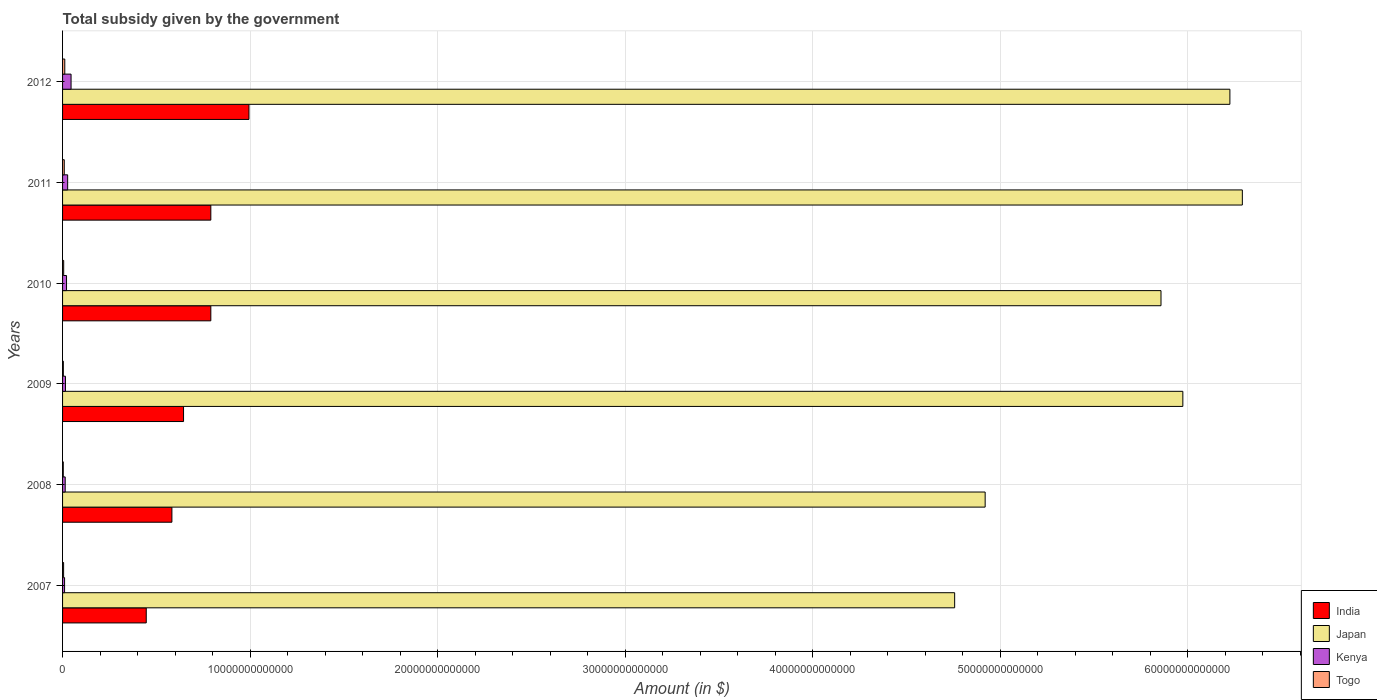How many different coloured bars are there?
Make the answer very short. 4. How many bars are there on the 2nd tick from the top?
Your answer should be very brief. 4. What is the label of the 3rd group of bars from the top?
Your answer should be very brief. 2010. What is the total revenue collected by the government in Togo in 2012?
Provide a succinct answer. 1.18e+11. Across all years, what is the maximum total revenue collected by the government in Kenya?
Provide a succinct answer. 4.53e+11. Across all years, what is the minimum total revenue collected by the government in India?
Offer a terse response. 4.46e+12. What is the total total revenue collected by the government in India in the graph?
Give a very brief answer. 4.25e+13. What is the difference between the total revenue collected by the government in India in 2009 and that in 2011?
Provide a succinct answer. -1.45e+12. What is the difference between the total revenue collected by the government in Togo in 2009 and the total revenue collected by the government in Japan in 2008?
Give a very brief answer. -4.92e+13. What is the average total revenue collected by the government in Kenya per year?
Your answer should be very brief. 2.23e+11. In the year 2009, what is the difference between the total revenue collected by the government in Japan and total revenue collected by the government in India?
Your response must be concise. 5.33e+13. What is the ratio of the total revenue collected by the government in Kenya in 2010 to that in 2012?
Your answer should be compact. 0.47. Is the total revenue collected by the government in Togo in 2010 less than that in 2012?
Provide a short and direct response. Yes. Is the difference between the total revenue collected by the government in Japan in 2008 and 2010 greater than the difference between the total revenue collected by the government in India in 2008 and 2010?
Ensure brevity in your answer.  No. What is the difference between the highest and the second highest total revenue collected by the government in Japan?
Your response must be concise. 6.64e+11. What is the difference between the highest and the lowest total revenue collected by the government in Kenya?
Ensure brevity in your answer.  3.46e+11. Is it the case that in every year, the sum of the total revenue collected by the government in Togo and total revenue collected by the government in Japan is greater than the sum of total revenue collected by the government in India and total revenue collected by the government in Kenya?
Make the answer very short. Yes. What does the 2nd bar from the top in 2012 represents?
Keep it short and to the point. Kenya. How many years are there in the graph?
Make the answer very short. 6. What is the difference between two consecutive major ticks on the X-axis?
Make the answer very short. 1.00e+13. Does the graph contain any zero values?
Your answer should be very brief. No. Does the graph contain grids?
Offer a terse response. Yes. What is the title of the graph?
Provide a short and direct response. Total subsidy given by the government. Does "Uzbekistan" appear as one of the legend labels in the graph?
Offer a very short reply. No. What is the label or title of the X-axis?
Make the answer very short. Amount (in $). What is the label or title of the Y-axis?
Provide a succinct answer. Years. What is the Amount (in $) of India in 2007?
Provide a short and direct response. 4.46e+12. What is the Amount (in $) of Japan in 2007?
Your answer should be compact. 4.76e+13. What is the Amount (in $) of Kenya in 2007?
Offer a terse response. 1.08e+11. What is the Amount (in $) of Togo in 2007?
Keep it short and to the point. 5.57e+1. What is the Amount (in $) in India in 2008?
Give a very brief answer. 5.83e+12. What is the Amount (in $) of Japan in 2008?
Give a very brief answer. 4.92e+13. What is the Amount (in $) in Kenya in 2008?
Provide a short and direct response. 1.41e+11. What is the Amount (in $) in Togo in 2008?
Your answer should be compact. 3.81e+1. What is the Amount (in $) in India in 2009?
Your answer should be compact. 6.45e+12. What is the Amount (in $) of Japan in 2009?
Offer a terse response. 5.97e+13. What is the Amount (in $) of Kenya in 2009?
Provide a succinct answer. 1.55e+11. What is the Amount (in $) in Togo in 2009?
Give a very brief answer. 4.11e+1. What is the Amount (in $) of India in 2010?
Your answer should be very brief. 7.90e+12. What is the Amount (in $) in Japan in 2010?
Your answer should be very brief. 5.86e+13. What is the Amount (in $) of Kenya in 2010?
Provide a succinct answer. 2.12e+11. What is the Amount (in $) in Togo in 2010?
Offer a terse response. 5.96e+1. What is the Amount (in $) in India in 2011?
Ensure brevity in your answer.  7.90e+12. What is the Amount (in $) in Japan in 2011?
Offer a very short reply. 6.29e+13. What is the Amount (in $) in Kenya in 2011?
Keep it short and to the point. 2.72e+11. What is the Amount (in $) of Togo in 2011?
Your response must be concise. 9.10e+1. What is the Amount (in $) in India in 2012?
Ensure brevity in your answer.  9.94e+12. What is the Amount (in $) of Japan in 2012?
Provide a succinct answer. 6.22e+13. What is the Amount (in $) in Kenya in 2012?
Keep it short and to the point. 4.53e+11. What is the Amount (in $) of Togo in 2012?
Provide a short and direct response. 1.18e+11. Across all years, what is the maximum Amount (in $) in India?
Ensure brevity in your answer.  9.94e+12. Across all years, what is the maximum Amount (in $) of Japan?
Make the answer very short. 6.29e+13. Across all years, what is the maximum Amount (in $) in Kenya?
Keep it short and to the point. 4.53e+11. Across all years, what is the maximum Amount (in $) in Togo?
Provide a succinct answer. 1.18e+11. Across all years, what is the minimum Amount (in $) of India?
Provide a succinct answer. 4.46e+12. Across all years, what is the minimum Amount (in $) in Japan?
Give a very brief answer. 4.76e+13. Across all years, what is the minimum Amount (in $) of Kenya?
Your response must be concise. 1.08e+11. Across all years, what is the minimum Amount (in $) in Togo?
Offer a very short reply. 3.81e+1. What is the total Amount (in $) in India in the graph?
Offer a terse response. 4.25e+13. What is the total Amount (in $) in Japan in the graph?
Your answer should be compact. 3.40e+14. What is the total Amount (in $) of Kenya in the graph?
Your response must be concise. 1.34e+12. What is the total Amount (in $) of Togo in the graph?
Your response must be concise. 4.03e+11. What is the difference between the Amount (in $) in India in 2007 and that in 2008?
Make the answer very short. -1.37e+12. What is the difference between the Amount (in $) of Japan in 2007 and that in 2008?
Your response must be concise. -1.63e+12. What is the difference between the Amount (in $) in Kenya in 2007 and that in 2008?
Your response must be concise. -3.34e+1. What is the difference between the Amount (in $) of Togo in 2007 and that in 2008?
Your response must be concise. 1.75e+1. What is the difference between the Amount (in $) in India in 2007 and that in 2009?
Ensure brevity in your answer.  -1.99e+12. What is the difference between the Amount (in $) in Japan in 2007 and that in 2009?
Ensure brevity in your answer.  -1.22e+13. What is the difference between the Amount (in $) in Kenya in 2007 and that in 2009?
Offer a terse response. -4.70e+1. What is the difference between the Amount (in $) of Togo in 2007 and that in 2009?
Your answer should be compact. 1.46e+1. What is the difference between the Amount (in $) in India in 2007 and that in 2010?
Provide a succinct answer. -3.44e+12. What is the difference between the Amount (in $) of Japan in 2007 and that in 2010?
Provide a short and direct response. -1.10e+13. What is the difference between the Amount (in $) in Kenya in 2007 and that in 2010?
Your answer should be compact. -1.04e+11. What is the difference between the Amount (in $) in Togo in 2007 and that in 2010?
Your answer should be compact. -3.97e+09. What is the difference between the Amount (in $) in India in 2007 and that in 2011?
Give a very brief answer. -3.44e+12. What is the difference between the Amount (in $) in Japan in 2007 and that in 2011?
Keep it short and to the point. -1.53e+13. What is the difference between the Amount (in $) in Kenya in 2007 and that in 2011?
Keep it short and to the point. -1.64e+11. What is the difference between the Amount (in $) of Togo in 2007 and that in 2011?
Ensure brevity in your answer.  -3.53e+1. What is the difference between the Amount (in $) in India in 2007 and that in 2012?
Provide a short and direct response. -5.48e+12. What is the difference between the Amount (in $) of Japan in 2007 and that in 2012?
Your response must be concise. -1.47e+13. What is the difference between the Amount (in $) of Kenya in 2007 and that in 2012?
Your answer should be very brief. -3.46e+11. What is the difference between the Amount (in $) in Togo in 2007 and that in 2012?
Give a very brief answer. -6.22e+1. What is the difference between the Amount (in $) in India in 2008 and that in 2009?
Give a very brief answer. -6.20e+11. What is the difference between the Amount (in $) in Japan in 2008 and that in 2009?
Your answer should be very brief. -1.05e+13. What is the difference between the Amount (in $) of Kenya in 2008 and that in 2009?
Provide a short and direct response. -1.37e+1. What is the difference between the Amount (in $) in Togo in 2008 and that in 2009?
Offer a terse response. -2.97e+09. What is the difference between the Amount (in $) of India in 2008 and that in 2010?
Your answer should be very brief. -2.07e+12. What is the difference between the Amount (in $) in Japan in 2008 and that in 2010?
Give a very brief answer. -9.38e+12. What is the difference between the Amount (in $) in Kenya in 2008 and that in 2010?
Offer a very short reply. -7.07e+1. What is the difference between the Amount (in $) in Togo in 2008 and that in 2010?
Ensure brevity in your answer.  -2.15e+1. What is the difference between the Amount (in $) in India in 2008 and that in 2011?
Offer a terse response. -2.07e+12. What is the difference between the Amount (in $) in Japan in 2008 and that in 2011?
Your answer should be very brief. -1.37e+13. What is the difference between the Amount (in $) in Kenya in 2008 and that in 2011?
Offer a terse response. -1.31e+11. What is the difference between the Amount (in $) of Togo in 2008 and that in 2011?
Your answer should be very brief. -5.28e+1. What is the difference between the Amount (in $) in India in 2008 and that in 2012?
Keep it short and to the point. -4.11e+12. What is the difference between the Amount (in $) in Japan in 2008 and that in 2012?
Ensure brevity in your answer.  -1.30e+13. What is the difference between the Amount (in $) in Kenya in 2008 and that in 2012?
Offer a very short reply. -3.12e+11. What is the difference between the Amount (in $) of Togo in 2008 and that in 2012?
Keep it short and to the point. -7.97e+1. What is the difference between the Amount (in $) in India in 2009 and that in 2010?
Your answer should be very brief. -1.45e+12. What is the difference between the Amount (in $) of Japan in 2009 and that in 2010?
Keep it short and to the point. 1.16e+12. What is the difference between the Amount (in $) of Kenya in 2009 and that in 2010?
Make the answer very short. -5.71e+1. What is the difference between the Amount (in $) of Togo in 2009 and that in 2010?
Offer a terse response. -1.85e+1. What is the difference between the Amount (in $) in India in 2009 and that in 2011?
Make the answer very short. -1.45e+12. What is the difference between the Amount (in $) in Japan in 2009 and that in 2011?
Make the answer very short. -3.17e+12. What is the difference between the Amount (in $) in Kenya in 2009 and that in 2011?
Provide a short and direct response. -1.17e+11. What is the difference between the Amount (in $) of Togo in 2009 and that in 2011?
Provide a short and direct response. -4.99e+1. What is the difference between the Amount (in $) in India in 2009 and that in 2012?
Your answer should be compact. -3.49e+12. What is the difference between the Amount (in $) in Japan in 2009 and that in 2012?
Ensure brevity in your answer.  -2.51e+12. What is the difference between the Amount (in $) of Kenya in 2009 and that in 2012?
Provide a short and direct response. -2.99e+11. What is the difference between the Amount (in $) in Togo in 2009 and that in 2012?
Offer a very short reply. -7.67e+1. What is the difference between the Amount (in $) of India in 2010 and that in 2011?
Your response must be concise. 0. What is the difference between the Amount (in $) in Japan in 2010 and that in 2011?
Offer a terse response. -4.34e+12. What is the difference between the Amount (in $) of Kenya in 2010 and that in 2011?
Provide a succinct answer. -6.00e+1. What is the difference between the Amount (in $) in Togo in 2010 and that in 2011?
Ensure brevity in your answer.  -3.13e+1. What is the difference between the Amount (in $) in India in 2010 and that in 2012?
Your answer should be very brief. -2.03e+12. What is the difference between the Amount (in $) in Japan in 2010 and that in 2012?
Provide a short and direct response. -3.67e+12. What is the difference between the Amount (in $) in Kenya in 2010 and that in 2012?
Ensure brevity in your answer.  -2.42e+11. What is the difference between the Amount (in $) in Togo in 2010 and that in 2012?
Offer a terse response. -5.82e+1. What is the difference between the Amount (in $) in India in 2011 and that in 2012?
Your answer should be compact. -2.03e+12. What is the difference between the Amount (in $) of Japan in 2011 and that in 2012?
Your answer should be very brief. 6.64e+11. What is the difference between the Amount (in $) of Kenya in 2011 and that in 2012?
Offer a terse response. -1.82e+11. What is the difference between the Amount (in $) in Togo in 2011 and that in 2012?
Ensure brevity in your answer.  -2.69e+1. What is the difference between the Amount (in $) in India in 2007 and the Amount (in $) in Japan in 2008?
Provide a short and direct response. -4.47e+13. What is the difference between the Amount (in $) of India in 2007 and the Amount (in $) of Kenya in 2008?
Keep it short and to the point. 4.32e+12. What is the difference between the Amount (in $) of India in 2007 and the Amount (in $) of Togo in 2008?
Provide a short and direct response. 4.42e+12. What is the difference between the Amount (in $) of Japan in 2007 and the Amount (in $) of Kenya in 2008?
Make the answer very short. 4.74e+13. What is the difference between the Amount (in $) in Japan in 2007 and the Amount (in $) in Togo in 2008?
Keep it short and to the point. 4.75e+13. What is the difference between the Amount (in $) in Kenya in 2007 and the Amount (in $) in Togo in 2008?
Give a very brief answer. 6.94e+1. What is the difference between the Amount (in $) in India in 2007 and the Amount (in $) in Japan in 2009?
Offer a very short reply. -5.53e+13. What is the difference between the Amount (in $) of India in 2007 and the Amount (in $) of Kenya in 2009?
Provide a succinct answer. 4.31e+12. What is the difference between the Amount (in $) in India in 2007 and the Amount (in $) in Togo in 2009?
Offer a terse response. 4.42e+12. What is the difference between the Amount (in $) in Japan in 2007 and the Amount (in $) in Kenya in 2009?
Your response must be concise. 4.74e+13. What is the difference between the Amount (in $) of Japan in 2007 and the Amount (in $) of Togo in 2009?
Your answer should be compact. 4.75e+13. What is the difference between the Amount (in $) in Kenya in 2007 and the Amount (in $) in Togo in 2009?
Your response must be concise. 6.65e+1. What is the difference between the Amount (in $) of India in 2007 and the Amount (in $) of Japan in 2010?
Your answer should be compact. -5.41e+13. What is the difference between the Amount (in $) of India in 2007 and the Amount (in $) of Kenya in 2010?
Your answer should be very brief. 4.25e+12. What is the difference between the Amount (in $) in India in 2007 and the Amount (in $) in Togo in 2010?
Your response must be concise. 4.40e+12. What is the difference between the Amount (in $) of Japan in 2007 and the Amount (in $) of Kenya in 2010?
Your answer should be compact. 4.74e+13. What is the difference between the Amount (in $) of Japan in 2007 and the Amount (in $) of Togo in 2010?
Offer a very short reply. 4.75e+13. What is the difference between the Amount (in $) in Kenya in 2007 and the Amount (in $) in Togo in 2010?
Your answer should be very brief. 4.79e+1. What is the difference between the Amount (in $) of India in 2007 and the Amount (in $) of Japan in 2011?
Provide a short and direct response. -5.84e+13. What is the difference between the Amount (in $) of India in 2007 and the Amount (in $) of Kenya in 2011?
Keep it short and to the point. 4.19e+12. What is the difference between the Amount (in $) of India in 2007 and the Amount (in $) of Togo in 2011?
Your answer should be compact. 4.37e+12. What is the difference between the Amount (in $) in Japan in 2007 and the Amount (in $) in Kenya in 2011?
Give a very brief answer. 4.73e+13. What is the difference between the Amount (in $) of Japan in 2007 and the Amount (in $) of Togo in 2011?
Ensure brevity in your answer.  4.75e+13. What is the difference between the Amount (in $) in Kenya in 2007 and the Amount (in $) in Togo in 2011?
Make the answer very short. 1.66e+1. What is the difference between the Amount (in $) in India in 2007 and the Amount (in $) in Japan in 2012?
Your answer should be very brief. -5.78e+13. What is the difference between the Amount (in $) in India in 2007 and the Amount (in $) in Kenya in 2012?
Your response must be concise. 4.01e+12. What is the difference between the Amount (in $) in India in 2007 and the Amount (in $) in Togo in 2012?
Keep it short and to the point. 4.34e+12. What is the difference between the Amount (in $) of Japan in 2007 and the Amount (in $) of Kenya in 2012?
Make the answer very short. 4.71e+13. What is the difference between the Amount (in $) of Japan in 2007 and the Amount (in $) of Togo in 2012?
Give a very brief answer. 4.74e+13. What is the difference between the Amount (in $) of Kenya in 2007 and the Amount (in $) of Togo in 2012?
Offer a very short reply. -1.03e+1. What is the difference between the Amount (in $) of India in 2008 and the Amount (in $) of Japan in 2009?
Keep it short and to the point. -5.39e+13. What is the difference between the Amount (in $) of India in 2008 and the Amount (in $) of Kenya in 2009?
Your answer should be compact. 5.68e+12. What is the difference between the Amount (in $) of India in 2008 and the Amount (in $) of Togo in 2009?
Your response must be concise. 5.79e+12. What is the difference between the Amount (in $) of Japan in 2008 and the Amount (in $) of Kenya in 2009?
Keep it short and to the point. 4.90e+13. What is the difference between the Amount (in $) of Japan in 2008 and the Amount (in $) of Togo in 2009?
Provide a short and direct response. 4.92e+13. What is the difference between the Amount (in $) in Kenya in 2008 and the Amount (in $) in Togo in 2009?
Ensure brevity in your answer.  9.98e+1. What is the difference between the Amount (in $) of India in 2008 and the Amount (in $) of Japan in 2010?
Give a very brief answer. -5.27e+13. What is the difference between the Amount (in $) in India in 2008 and the Amount (in $) in Kenya in 2010?
Provide a succinct answer. 5.62e+12. What is the difference between the Amount (in $) in India in 2008 and the Amount (in $) in Togo in 2010?
Your answer should be compact. 5.77e+12. What is the difference between the Amount (in $) of Japan in 2008 and the Amount (in $) of Kenya in 2010?
Provide a short and direct response. 4.90e+13. What is the difference between the Amount (in $) of Japan in 2008 and the Amount (in $) of Togo in 2010?
Offer a very short reply. 4.91e+13. What is the difference between the Amount (in $) of Kenya in 2008 and the Amount (in $) of Togo in 2010?
Offer a very short reply. 8.13e+1. What is the difference between the Amount (in $) of India in 2008 and the Amount (in $) of Japan in 2011?
Your answer should be very brief. -5.71e+13. What is the difference between the Amount (in $) of India in 2008 and the Amount (in $) of Kenya in 2011?
Provide a succinct answer. 5.56e+12. What is the difference between the Amount (in $) in India in 2008 and the Amount (in $) in Togo in 2011?
Your answer should be compact. 5.74e+12. What is the difference between the Amount (in $) in Japan in 2008 and the Amount (in $) in Kenya in 2011?
Offer a very short reply. 4.89e+13. What is the difference between the Amount (in $) in Japan in 2008 and the Amount (in $) in Togo in 2011?
Offer a terse response. 4.91e+13. What is the difference between the Amount (in $) of Kenya in 2008 and the Amount (in $) of Togo in 2011?
Provide a succinct answer. 5.00e+1. What is the difference between the Amount (in $) in India in 2008 and the Amount (in $) in Japan in 2012?
Your answer should be very brief. -5.64e+13. What is the difference between the Amount (in $) in India in 2008 and the Amount (in $) in Kenya in 2012?
Offer a very short reply. 5.38e+12. What is the difference between the Amount (in $) in India in 2008 and the Amount (in $) in Togo in 2012?
Make the answer very short. 5.71e+12. What is the difference between the Amount (in $) in Japan in 2008 and the Amount (in $) in Kenya in 2012?
Provide a short and direct response. 4.87e+13. What is the difference between the Amount (in $) of Japan in 2008 and the Amount (in $) of Togo in 2012?
Make the answer very short. 4.91e+13. What is the difference between the Amount (in $) of Kenya in 2008 and the Amount (in $) of Togo in 2012?
Ensure brevity in your answer.  2.31e+1. What is the difference between the Amount (in $) in India in 2009 and the Amount (in $) in Japan in 2010?
Provide a short and direct response. -5.21e+13. What is the difference between the Amount (in $) in India in 2009 and the Amount (in $) in Kenya in 2010?
Offer a very short reply. 6.24e+12. What is the difference between the Amount (in $) of India in 2009 and the Amount (in $) of Togo in 2010?
Offer a terse response. 6.39e+12. What is the difference between the Amount (in $) of Japan in 2009 and the Amount (in $) of Kenya in 2010?
Provide a short and direct response. 5.95e+13. What is the difference between the Amount (in $) in Japan in 2009 and the Amount (in $) in Togo in 2010?
Your answer should be compact. 5.97e+13. What is the difference between the Amount (in $) of Kenya in 2009 and the Amount (in $) of Togo in 2010?
Offer a very short reply. 9.50e+1. What is the difference between the Amount (in $) of India in 2009 and the Amount (in $) of Japan in 2011?
Ensure brevity in your answer.  -5.65e+13. What is the difference between the Amount (in $) in India in 2009 and the Amount (in $) in Kenya in 2011?
Offer a very short reply. 6.18e+12. What is the difference between the Amount (in $) of India in 2009 and the Amount (in $) of Togo in 2011?
Ensure brevity in your answer.  6.36e+12. What is the difference between the Amount (in $) of Japan in 2009 and the Amount (in $) of Kenya in 2011?
Offer a terse response. 5.95e+13. What is the difference between the Amount (in $) of Japan in 2009 and the Amount (in $) of Togo in 2011?
Your response must be concise. 5.96e+13. What is the difference between the Amount (in $) in Kenya in 2009 and the Amount (in $) in Togo in 2011?
Offer a terse response. 6.36e+1. What is the difference between the Amount (in $) in India in 2009 and the Amount (in $) in Japan in 2012?
Provide a short and direct response. -5.58e+13. What is the difference between the Amount (in $) of India in 2009 and the Amount (in $) of Kenya in 2012?
Your answer should be very brief. 6.00e+12. What is the difference between the Amount (in $) in India in 2009 and the Amount (in $) in Togo in 2012?
Your response must be concise. 6.33e+12. What is the difference between the Amount (in $) in Japan in 2009 and the Amount (in $) in Kenya in 2012?
Provide a succinct answer. 5.93e+13. What is the difference between the Amount (in $) in Japan in 2009 and the Amount (in $) in Togo in 2012?
Ensure brevity in your answer.  5.96e+13. What is the difference between the Amount (in $) of Kenya in 2009 and the Amount (in $) of Togo in 2012?
Provide a short and direct response. 3.68e+1. What is the difference between the Amount (in $) of India in 2010 and the Amount (in $) of Japan in 2011?
Your answer should be very brief. -5.50e+13. What is the difference between the Amount (in $) in India in 2010 and the Amount (in $) in Kenya in 2011?
Give a very brief answer. 7.63e+12. What is the difference between the Amount (in $) in India in 2010 and the Amount (in $) in Togo in 2011?
Ensure brevity in your answer.  7.81e+12. What is the difference between the Amount (in $) in Japan in 2010 and the Amount (in $) in Kenya in 2011?
Your response must be concise. 5.83e+13. What is the difference between the Amount (in $) in Japan in 2010 and the Amount (in $) in Togo in 2011?
Make the answer very short. 5.85e+13. What is the difference between the Amount (in $) in Kenya in 2010 and the Amount (in $) in Togo in 2011?
Give a very brief answer. 1.21e+11. What is the difference between the Amount (in $) in India in 2010 and the Amount (in $) in Japan in 2012?
Keep it short and to the point. -5.43e+13. What is the difference between the Amount (in $) of India in 2010 and the Amount (in $) of Kenya in 2012?
Give a very brief answer. 7.45e+12. What is the difference between the Amount (in $) in India in 2010 and the Amount (in $) in Togo in 2012?
Give a very brief answer. 7.79e+12. What is the difference between the Amount (in $) in Japan in 2010 and the Amount (in $) in Kenya in 2012?
Provide a succinct answer. 5.81e+13. What is the difference between the Amount (in $) in Japan in 2010 and the Amount (in $) in Togo in 2012?
Your answer should be very brief. 5.84e+13. What is the difference between the Amount (in $) in Kenya in 2010 and the Amount (in $) in Togo in 2012?
Keep it short and to the point. 9.38e+1. What is the difference between the Amount (in $) of India in 2011 and the Amount (in $) of Japan in 2012?
Give a very brief answer. -5.43e+13. What is the difference between the Amount (in $) in India in 2011 and the Amount (in $) in Kenya in 2012?
Ensure brevity in your answer.  7.45e+12. What is the difference between the Amount (in $) of India in 2011 and the Amount (in $) of Togo in 2012?
Offer a very short reply. 7.79e+12. What is the difference between the Amount (in $) in Japan in 2011 and the Amount (in $) in Kenya in 2012?
Keep it short and to the point. 6.25e+13. What is the difference between the Amount (in $) in Japan in 2011 and the Amount (in $) in Togo in 2012?
Give a very brief answer. 6.28e+13. What is the difference between the Amount (in $) of Kenya in 2011 and the Amount (in $) of Togo in 2012?
Your answer should be very brief. 1.54e+11. What is the average Amount (in $) in India per year?
Ensure brevity in your answer.  7.08e+12. What is the average Amount (in $) of Japan per year?
Offer a terse response. 5.67e+13. What is the average Amount (in $) in Kenya per year?
Your answer should be compact. 2.23e+11. What is the average Amount (in $) in Togo per year?
Give a very brief answer. 6.72e+1. In the year 2007, what is the difference between the Amount (in $) of India and Amount (in $) of Japan?
Provide a short and direct response. -4.31e+13. In the year 2007, what is the difference between the Amount (in $) in India and Amount (in $) in Kenya?
Your answer should be compact. 4.35e+12. In the year 2007, what is the difference between the Amount (in $) in India and Amount (in $) in Togo?
Offer a terse response. 4.41e+12. In the year 2007, what is the difference between the Amount (in $) in Japan and Amount (in $) in Kenya?
Keep it short and to the point. 4.75e+13. In the year 2007, what is the difference between the Amount (in $) in Japan and Amount (in $) in Togo?
Offer a terse response. 4.75e+13. In the year 2007, what is the difference between the Amount (in $) of Kenya and Amount (in $) of Togo?
Give a very brief answer. 5.19e+1. In the year 2008, what is the difference between the Amount (in $) of India and Amount (in $) of Japan?
Offer a very short reply. -4.34e+13. In the year 2008, what is the difference between the Amount (in $) of India and Amount (in $) of Kenya?
Your answer should be very brief. 5.69e+12. In the year 2008, what is the difference between the Amount (in $) of India and Amount (in $) of Togo?
Make the answer very short. 5.79e+12. In the year 2008, what is the difference between the Amount (in $) of Japan and Amount (in $) of Kenya?
Your response must be concise. 4.91e+13. In the year 2008, what is the difference between the Amount (in $) in Japan and Amount (in $) in Togo?
Give a very brief answer. 4.92e+13. In the year 2008, what is the difference between the Amount (in $) in Kenya and Amount (in $) in Togo?
Make the answer very short. 1.03e+11. In the year 2009, what is the difference between the Amount (in $) of India and Amount (in $) of Japan?
Your answer should be very brief. -5.33e+13. In the year 2009, what is the difference between the Amount (in $) of India and Amount (in $) of Kenya?
Make the answer very short. 6.30e+12. In the year 2009, what is the difference between the Amount (in $) of India and Amount (in $) of Togo?
Keep it short and to the point. 6.41e+12. In the year 2009, what is the difference between the Amount (in $) in Japan and Amount (in $) in Kenya?
Your response must be concise. 5.96e+13. In the year 2009, what is the difference between the Amount (in $) in Japan and Amount (in $) in Togo?
Your answer should be compact. 5.97e+13. In the year 2009, what is the difference between the Amount (in $) of Kenya and Amount (in $) of Togo?
Give a very brief answer. 1.14e+11. In the year 2010, what is the difference between the Amount (in $) of India and Amount (in $) of Japan?
Keep it short and to the point. -5.07e+13. In the year 2010, what is the difference between the Amount (in $) in India and Amount (in $) in Kenya?
Make the answer very short. 7.69e+12. In the year 2010, what is the difference between the Amount (in $) of India and Amount (in $) of Togo?
Give a very brief answer. 7.85e+12. In the year 2010, what is the difference between the Amount (in $) of Japan and Amount (in $) of Kenya?
Your answer should be very brief. 5.84e+13. In the year 2010, what is the difference between the Amount (in $) in Japan and Amount (in $) in Togo?
Your answer should be compact. 5.85e+13. In the year 2010, what is the difference between the Amount (in $) in Kenya and Amount (in $) in Togo?
Offer a terse response. 1.52e+11. In the year 2011, what is the difference between the Amount (in $) in India and Amount (in $) in Japan?
Provide a short and direct response. -5.50e+13. In the year 2011, what is the difference between the Amount (in $) of India and Amount (in $) of Kenya?
Offer a terse response. 7.63e+12. In the year 2011, what is the difference between the Amount (in $) of India and Amount (in $) of Togo?
Provide a succinct answer. 7.81e+12. In the year 2011, what is the difference between the Amount (in $) in Japan and Amount (in $) in Kenya?
Provide a succinct answer. 6.26e+13. In the year 2011, what is the difference between the Amount (in $) in Japan and Amount (in $) in Togo?
Make the answer very short. 6.28e+13. In the year 2011, what is the difference between the Amount (in $) of Kenya and Amount (in $) of Togo?
Ensure brevity in your answer.  1.81e+11. In the year 2012, what is the difference between the Amount (in $) in India and Amount (in $) in Japan?
Your response must be concise. -5.23e+13. In the year 2012, what is the difference between the Amount (in $) in India and Amount (in $) in Kenya?
Your response must be concise. 9.49e+12. In the year 2012, what is the difference between the Amount (in $) in India and Amount (in $) in Togo?
Your answer should be compact. 9.82e+12. In the year 2012, what is the difference between the Amount (in $) in Japan and Amount (in $) in Kenya?
Give a very brief answer. 6.18e+13. In the year 2012, what is the difference between the Amount (in $) in Japan and Amount (in $) in Togo?
Ensure brevity in your answer.  6.21e+13. In the year 2012, what is the difference between the Amount (in $) of Kenya and Amount (in $) of Togo?
Your response must be concise. 3.36e+11. What is the ratio of the Amount (in $) in India in 2007 to that in 2008?
Your response must be concise. 0.77. What is the ratio of the Amount (in $) of Japan in 2007 to that in 2008?
Offer a terse response. 0.97. What is the ratio of the Amount (in $) of Kenya in 2007 to that in 2008?
Give a very brief answer. 0.76. What is the ratio of the Amount (in $) in Togo in 2007 to that in 2008?
Offer a terse response. 1.46. What is the ratio of the Amount (in $) in India in 2007 to that in 2009?
Give a very brief answer. 0.69. What is the ratio of the Amount (in $) in Japan in 2007 to that in 2009?
Provide a succinct answer. 0.8. What is the ratio of the Amount (in $) in Kenya in 2007 to that in 2009?
Your answer should be very brief. 0.7. What is the ratio of the Amount (in $) in Togo in 2007 to that in 2009?
Your answer should be compact. 1.35. What is the ratio of the Amount (in $) of India in 2007 to that in 2010?
Make the answer very short. 0.56. What is the ratio of the Amount (in $) of Japan in 2007 to that in 2010?
Provide a short and direct response. 0.81. What is the ratio of the Amount (in $) in Kenya in 2007 to that in 2010?
Make the answer very short. 0.51. What is the ratio of the Amount (in $) in Togo in 2007 to that in 2010?
Provide a short and direct response. 0.93. What is the ratio of the Amount (in $) of India in 2007 to that in 2011?
Provide a succinct answer. 0.56. What is the ratio of the Amount (in $) of Japan in 2007 to that in 2011?
Offer a very short reply. 0.76. What is the ratio of the Amount (in $) in Kenya in 2007 to that in 2011?
Offer a very short reply. 0.4. What is the ratio of the Amount (in $) of Togo in 2007 to that in 2011?
Offer a very short reply. 0.61. What is the ratio of the Amount (in $) in India in 2007 to that in 2012?
Your response must be concise. 0.45. What is the ratio of the Amount (in $) in Japan in 2007 to that in 2012?
Provide a short and direct response. 0.76. What is the ratio of the Amount (in $) in Kenya in 2007 to that in 2012?
Provide a succinct answer. 0.24. What is the ratio of the Amount (in $) in Togo in 2007 to that in 2012?
Your answer should be compact. 0.47. What is the ratio of the Amount (in $) in India in 2008 to that in 2009?
Give a very brief answer. 0.9. What is the ratio of the Amount (in $) of Japan in 2008 to that in 2009?
Offer a very short reply. 0.82. What is the ratio of the Amount (in $) in Kenya in 2008 to that in 2009?
Offer a very short reply. 0.91. What is the ratio of the Amount (in $) in Togo in 2008 to that in 2009?
Your response must be concise. 0.93. What is the ratio of the Amount (in $) of India in 2008 to that in 2010?
Your answer should be compact. 0.74. What is the ratio of the Amount (in $) of Japan in 2008 to that in 2010?
Provide a short and direct response. 0.84. What is the ratio of the Amount (in $) of Kenya in 2008 to that in 2010?
Make the answer very short. 0.67. What is the ratio of the Amount (in $) in Togo in 2008 to that in 2010?
Your answer should be very brief. 0.64. What is the ratio of the Amount (in $) of India in 2008 to that in 2011?
Your answer should be very brief. 0.74. What is the ratio of the Amount (in $) of Japan in 2008 to that in 2011?
Make the answer very short. 0.78. What is the ratio of the Amount (in $) in Kenya in 2008 to that in 2011?
Your answer should be very brief. 0.52. What is the ratio of the Amount (in $) of Togo in 2008 to that in 2011?
Make the answer very short. 0.42. What is the ratio of the Amount (in $) of India in 2008 to that in 2012?
Keep it short and to the point. 0.59. What is the ratio of the Amount (in $) in Japan in 2008 to that in 2012?
Ensure brevity in your answer.  0.79. What is the ratio of the Amount (in $) of Kenya in 2008 to that in 2012?
Keep it short and to the point. 0.31. What is the ratio of the Amount (in $) of Togo in 2008 to that in 2012?
Provide a short and direct response. 0.32. What is the ratio of the Amount (in $) in India in 2009 to that in 2010?
Keep it short and to the point. 0.82. What is the ratio of the Amount (in $) of Japan in 2009 to that in 2010?
Keep it short and to the point. 1.02. What is the ratio of the Amount (in $) in Kenya in 2009 to that in 2010?
Make the answer very short. 0.73. What is the ratio of the Amount (in $) in Togo in 2009 to that in 2010?
Provide a short and direct response. 0.69. What is the ratio of the Amount (in $) in India in 2009 to that in 2011?
Ensure brevity in your answer.  0.82. What is the ratio of the Amount (in $) in Japan in 2009 to that in 2011?
Make the answer very short. 0.95. What is the ratio of the Amount (in $) of Kenya in 2009 to that in 2011?
Your answer should be very brief. 0.57. What is the ratio of the Amount (in $) of Togo in 2009 to that in 2011?
Your answer should be very brief. 0.45. What is the ratio of the Amount (in $) in India in 2009 to that in 2012?
Your answer should be compact. 0.65. What is the ratio of the Amount (in $) of Japan in 2009 to that in 2012?
Your answer should be very brief. 0.96. What is the ratio of the Amount (in $) of Kenya in 2009 to that in 2012?
Provide a short and direct response. 0.34. What is the ratio of the Amount (in $) of Togo in 2009 to that in 2012?
Make the answer very short. 0.35. What is the ratio of the Amount (in $) of India in 2010 to that in 2011?
Ensure brevity in your answer.  1. What is the ratio of the Amount (in $) in Japan in 2010 to that in 2011?
Provide a succinct answer. 0.93. What is the ratio of the Amount (in $) of Kenya in 2010 to that in 2011?
Provide a short and direct response. 0.78. What is the ratio of the Amount (in $) of Togo in 2010 to that in 2011?
Give a very brief answer. 0.66. What is the ratio of the Amount (in $) of India in 2010 to that in 2012?
Your answer should be very brief. 0.8. What is the ratio of the Amount (in $) of Japan in 2010 to that in 2012?
Offer a very short reply. 0.94. What is the ratio of the Amount (in $) in Kenya in 2010 to that in 2012?
Keep it short and to the point. 0.47. What is the ratio of the Amount (in $) of Togo in 2010 to that in 2012?
Your answer should be very brief. 0.51. What is the ratio of the Amount (in $) in India in 2011 to that in 2012?
Your answer should be very brief. 0.8. What is the ratio of the Amount (in $) of Japan in 2011 to that in 2012?
Your answer should be compact. 1.01. What is the ratio of the Amount (in $) of Kenya in 2011 to that in 2012?
Provide a succinct answer. 0.6. What is the ratio of the Amount (in $) of Togo in 2011 to that in 2012?
Keep it short and to the point. 0.77. What is the difference between the highest and the second highest Amount (in $) in India?
Your answer should be very brief. 2.03e+12. What is the difference between the highest and the second highest Amount (in $) of Japan?
Provide a succinct answer. 6.64e+11. What is the difference between the highest and the second highest Amount (in $) of Kenya?
Give a very brief answer. 1.82e+11. What is the difference between the highest and the second highest Amount (in $) of Togo?
Give a very brief answer. 2.69e+1. What is the difference between the highest and the lowest Amount (in $) in India?
Your answer should be very brief. 5.48e+12. What is the difference between the highest and the lowest Amount (in $) in Japan?
Ensure brevity in your answer.  1.53e+13. What is the difference between the highest and the lowest Amount (in $) of Kenya?
Ensure brevity in your answer.  3.46e+11. What is the difference between the highest and the lowest Amount (in $) in Togo?
Give a very brief answer. 7.97e+1. 